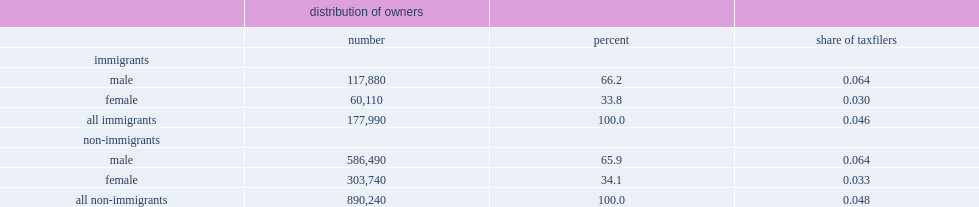Parse the table in full. {'header': ['', 'distribution of owners', '', ''], 'rows': [['', 'number', 'percent', 'share of taxfilers'], ['immigrants', '', '', ''], ['male', '117,880', '66.2', '0.064'], ['female', '60,110', '33.8', '0.030'], ['all immigrants', '177,990', '100.0', '0.046'], ['non-immigrants', '', '', ''], ['male', '586,490', '65.9', '0.064'], ['female', '303,740', '34.1', '0.033'], ['all non-immigrants', '890,240', '100.0', '0.048']]} How many times were men more likely to be owners among both immigrants and the comparison group? 1.961071. 